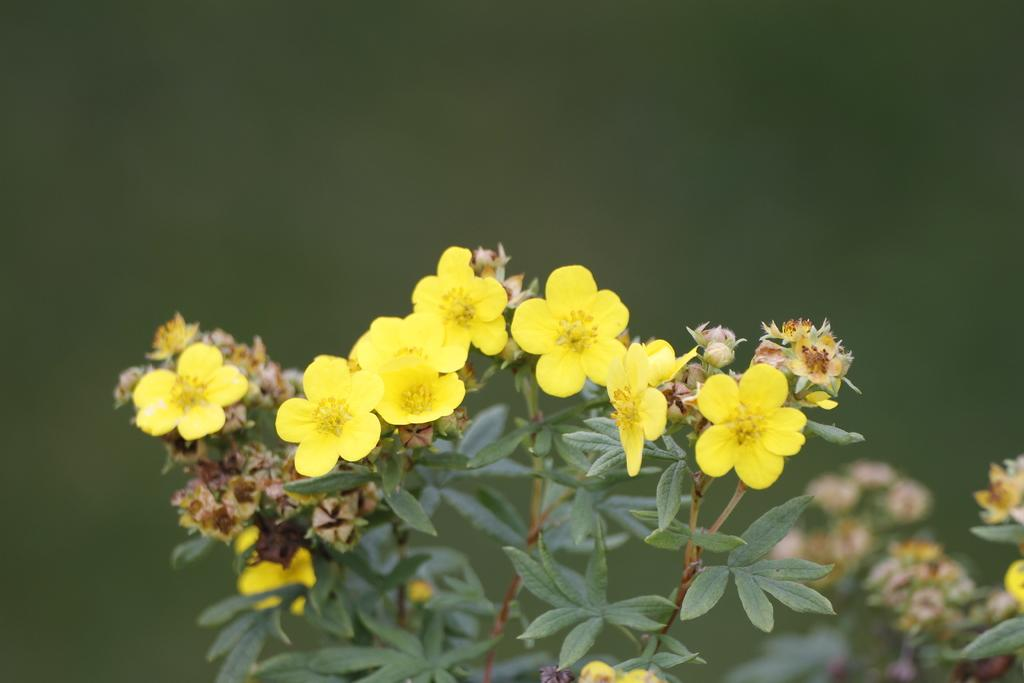What type of plants can be seen in the image? There are flower plants in the image. What color are the flowers on the plants? The flowers are yellow in color. Can you describe the background of the image? The background of the image is blurred. What type of amusement can be seen in the alley behind the flower plants? There is no alley or amusement present in the image; it only features flower plants with yellow flowers and a blurred background. 